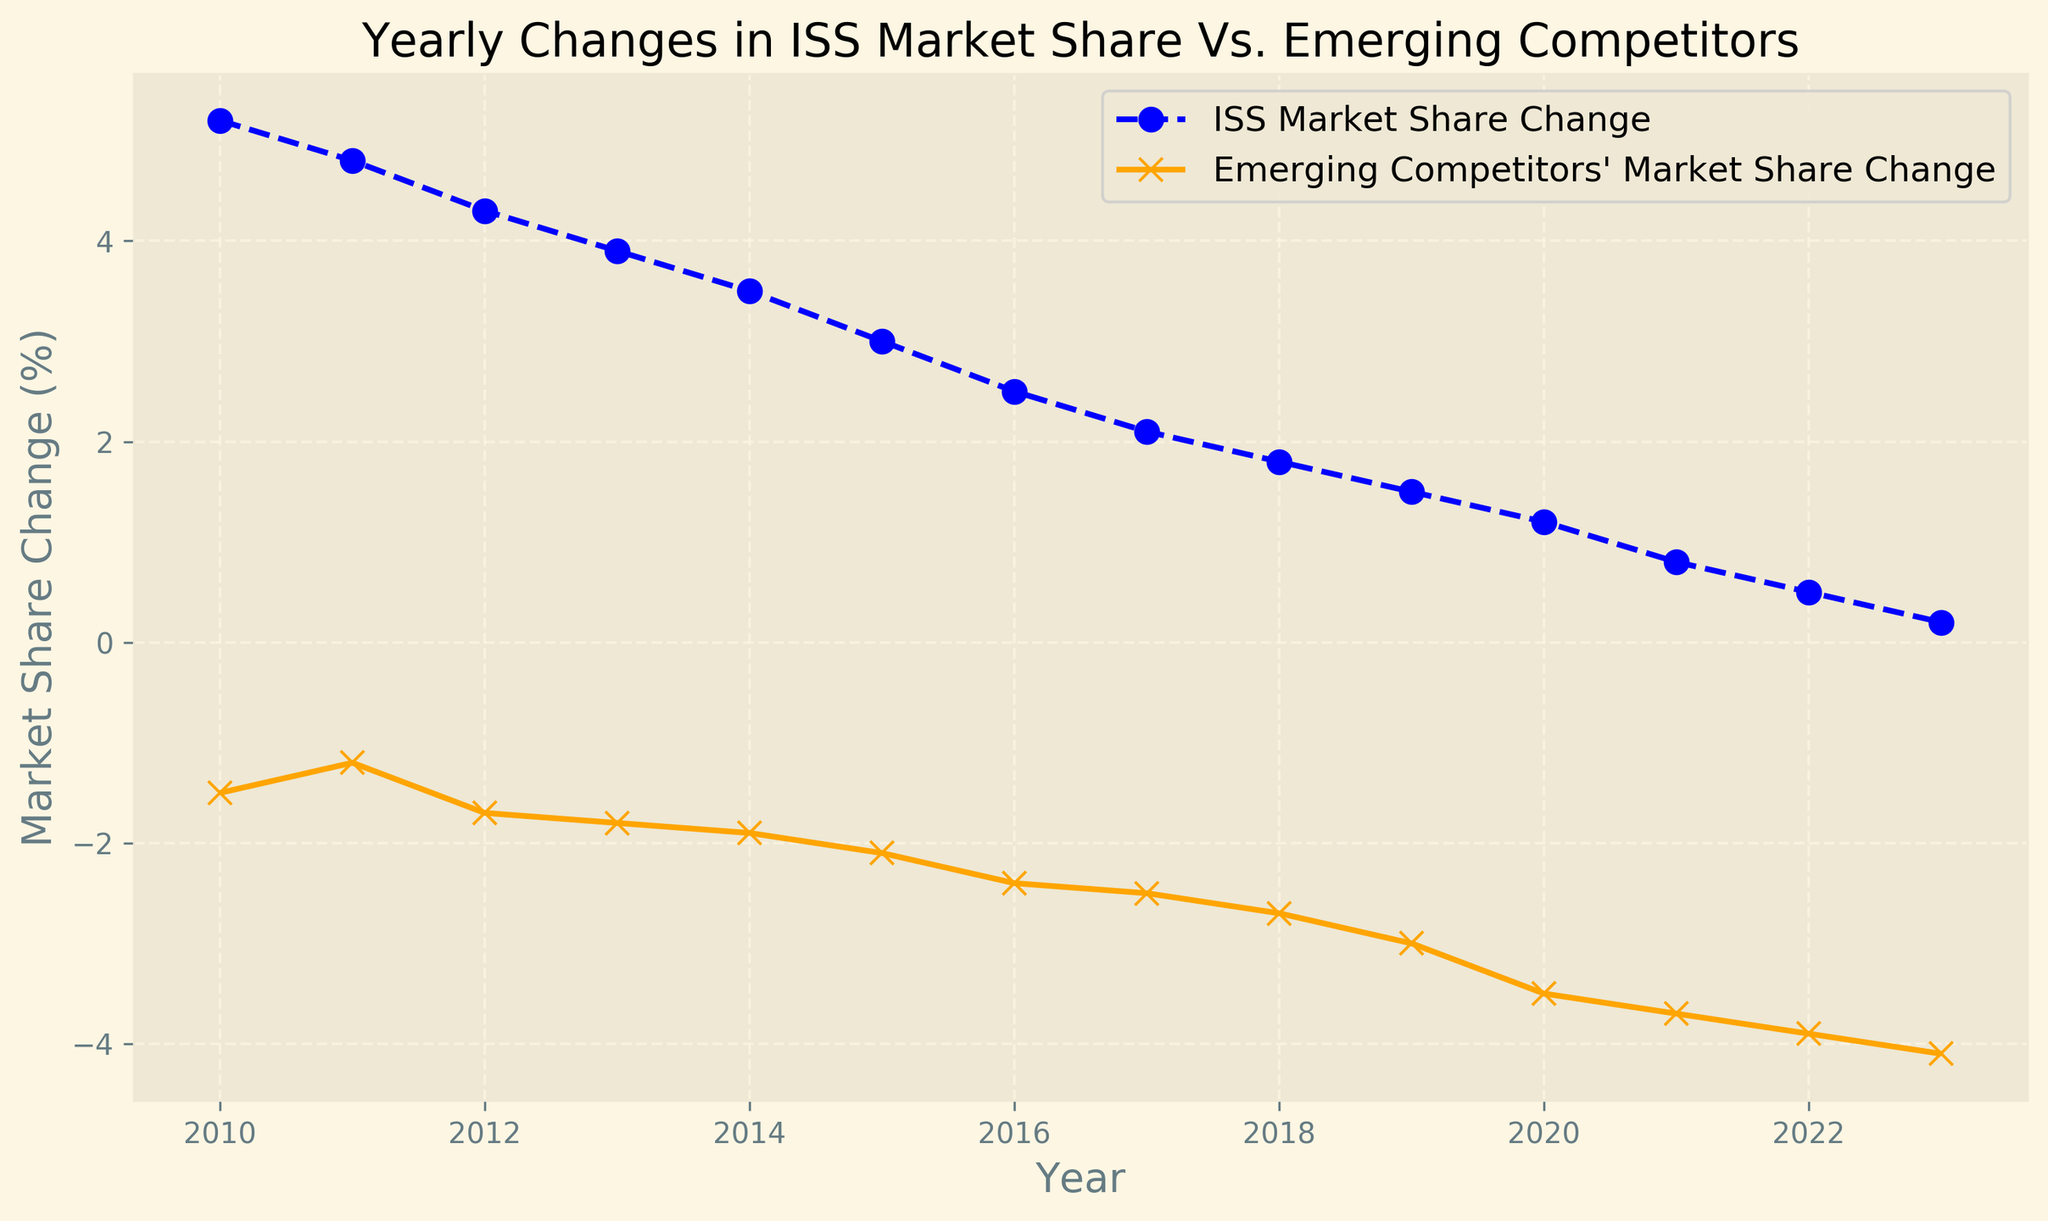What is the overall trend of ISS's market share change from 2010 to 2023? Observe the blue dashed line representing ISS Market Share Change. It consistently decreases from 5.2% in 2010 to 0.2% in 2023. Thus, the trend is a steady decline.
Answer: Steady decline Compare the market share change between ISS and Emerging Competitors in 2023. Look at the values in 2023 for both lines. ISS has a change of 0.2%, while Emerging Competitors have a change of -4.1%.
Answer: ISS's change is 0.2%, and Emerging Competitors' change is -4.1% During which year did ISS see the highest market share change, and what was that value? The peak point on the blue dashed line occurs in 2010 with a value of 5.2%.
Answer: 2010, 5.2% How much did the market share change of Emerging Competitors decrease from 2010 to 2023? The market share change starts at -1.5% in 2010 and ends at -4.1% in 2023. The decrease is calculated as -4.1% - (-1.5%) = -2.6%.
Answer: -2.6% Which year shows the smallest difference between ISS and Emerging Competitors' market share changes? To find the smallest difference, compare the absolute differences each year: 6.7, 6.0, 6.0, 5.7, 5.4, 5.1, 4.9, 4.6, 4.5, 4.5, 4.7, 4.5, 4.4, 4.3. The smallest difference is in 2023 with 4.3.
Answer: 2023 What is the average yearly market share change for ISS from 2010 to 2023? Add all the values for ISS (5.2 + 4.8 + 4.3 + 3.9 + 3.5 + 3.0 + 2.5 + 2.1 + 1.8 + 1.5 + 1.2 + 0.8 + 0.5 + 0.2) and divide by 14 (number of years). The total sum is 35.3, so the average is 35.3 / 14 = 2.52%.
Answer: 2.52% Which year had the sharpest decline in ISS market share change compared to the previous year? Calculate the difference year-over-year for ISS: (0.2-0.5), (0.5-0.8), (0.8-1.2), (1.2-1.5), (1.5-1.8), (1.8-2.1), (2.1-2.5), (2.5-3.0), (3.0-3.5), (3.5-3.9), (3.9-4.3), (4.3-4.8), (4.8-5.2). The largest negative difference is between 2010 and 2011: 5.2 - 4.8 = 0.4.
Answer: 2011 How does the color of the lines representing ISS and Emerging Competitors differ in the chart? The ISS Market Share Change line is blue and dashed, while the Emerging Competitors' Market Share Change line is orange and solid.
Answer: ISS is blue and dashed; Emerging Competitors is orange and solid Among the values from 2010 to 2023, which year has the most significant negative change for Emerging Competitors? The lowest (most negative) point on the orange solid line is in 2023 with a value of -4.1%.
Answer: 2023 